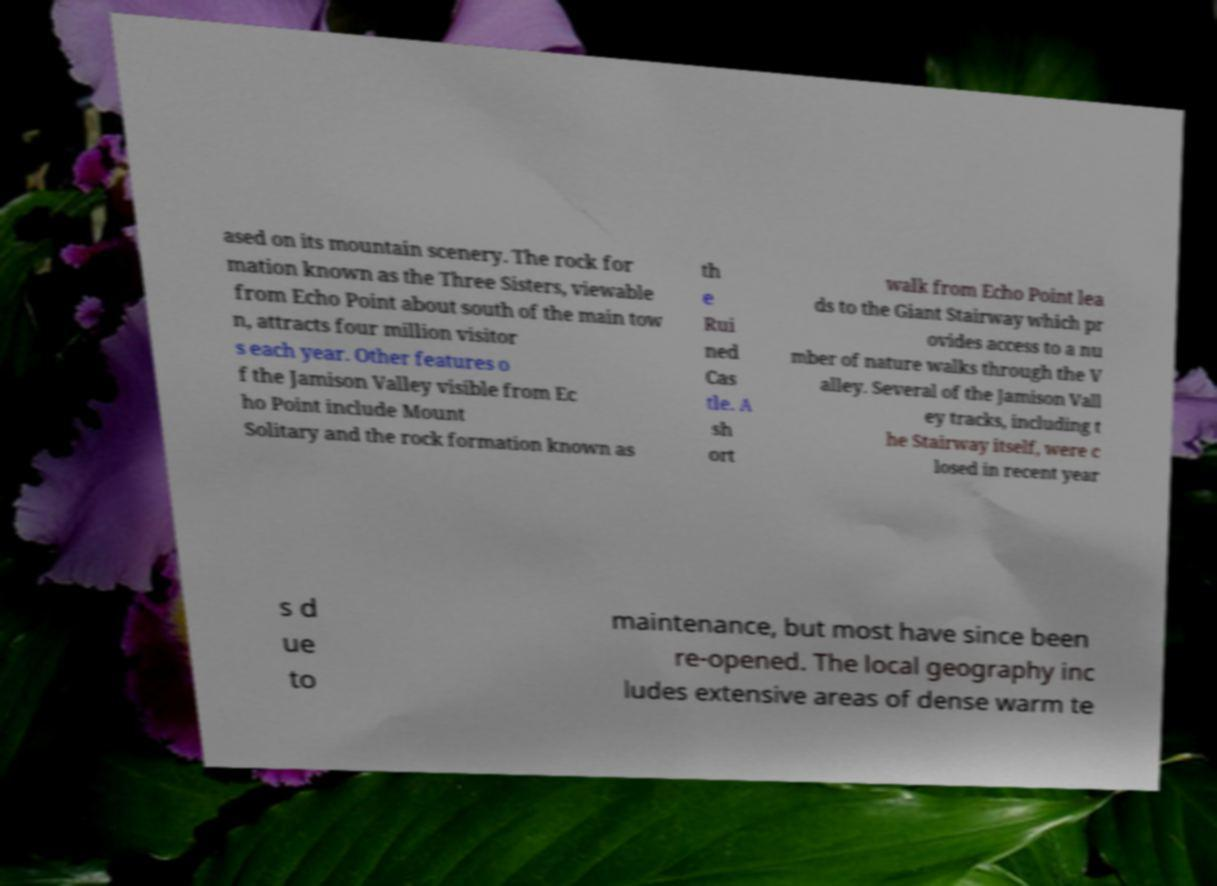Please read and relay the text visible in this image. What does it say? ased on its mountain scenery. The rock for mation known as the Three Sisters, viewable from Echo Point about south of the main tow n, attracts four million visitor s each year. Other features o f the Jamison Valley visible from Ec ho Point include Mount Solitary and the rock formation known as th e Rui ned Cas tle. A sh ort walk from Echo Point lea ds to the Giant Stairway which pr ovides access to a nu mber of nature walks through the V alley. Several of the Jamison Vall ey tracks, including t he Stairway itself, were c losed in recent year s d ue to maintenance, but most have since been re-opened. The local geography inc ludes extensive areas of dense warm te 